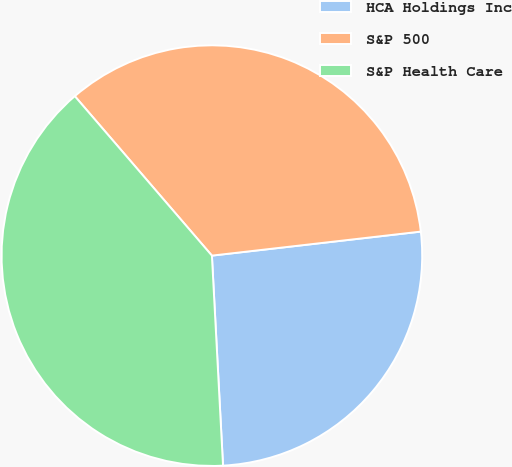<chart> <loc_0><loc_0><loc_500><loc_500><pie_chart><fcel>HCA Holdings Inc<fcel>S&P 500<fcel>S&P Health Care<nl><fcel>25.98%<fcel>34.48%<fcel>39.54%<nl></chart> 